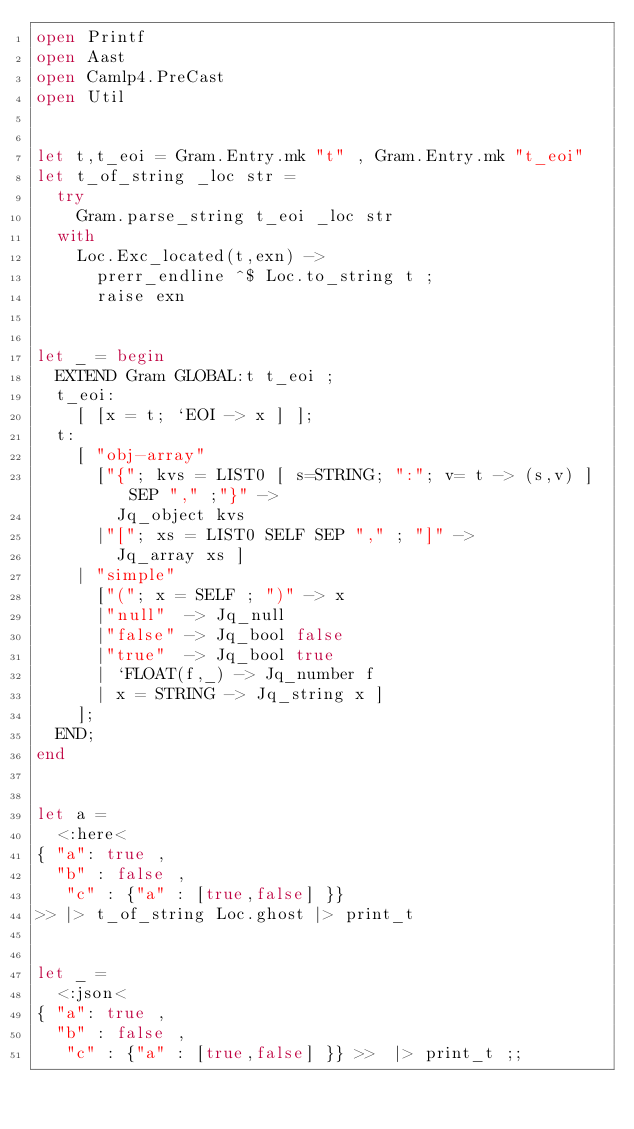Convert code to text. <code><loc_0><loc_0><loc_500><loc_500><_OCaml_>open Printf
open Aast
open Camlp4.PreCast
open Util

  
let t,t_eoi = Gram.Entry.mk "t" , Gram.Entry.mk "t_eoi"   
let t_of_string _loc str =
  try
    Gram.parse_string t_eoi _loc str
  with
    Loc.Exc_located(t,exn) -> 
      prerr_endline ^$ Loc.to_string t ;
      raise exn

	
let _ = begin
  EXTEND Gram GLOBAL:t t_eoi ;
  t_eoi:
    [ [x = t; `EOI -> x ] ];
  t:
    [ "obj-array"
      ["{"; kvs = LIST0 [ s=STRING; ":"; v= t -> (s,v) ] SEP "," ;"}" ->
        Jq_object kvs
      |"["; xs = LIST0 SELF SEP "," ; "]" ->
        Jq_array xs ]
    | "simple"
      ["("; x = SELF ; ")" -> x
      |"null"  -> Jq_null
      |"false" -> Jq_bool false
      |"true"  -> Jq_bool true
      | `FLOAT(f,_) -> Jq_number f 
      | x = STRING -> Jq_string x ]	
    ];
  END;
end 


let a =
  <:here<
{ "a": true ,
  "b" : false ,
   "c" : {"a" : [true,false] }}
>> |> t_of_string Loc.ghost |> print_t 
    

let _ =
  <:json<
{ "a": true ,
  "b" : false ,
   "c" : {"a" : [true,false] }} >>  |> print_t ;;










</code> 